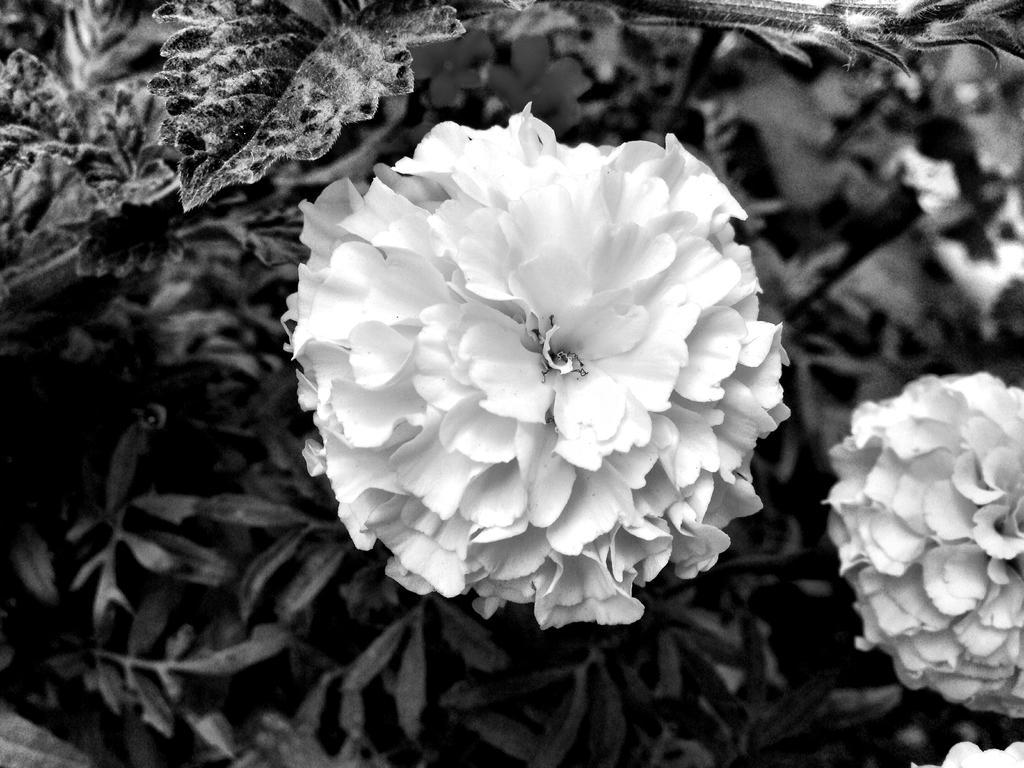Please provide a concise description of this image. In this image we can see flowers and some leaves. 